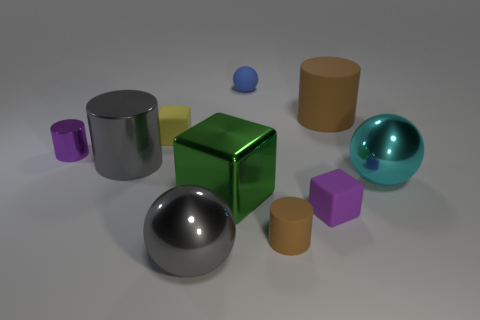Subtract all purple cylinders. How many cylinders are left? 3 Subtract all cyan spheres. How many spheres are left? 2 Subtract all spheres. How many objects are left? 7 Subtract 2 blocks. How many blocks are left? 1 Add 4 small purple shiny cylinders. How many small purple shiny cylinders are left? 5 Add 8 gray cylinders. How many gray cylinders exist? 9 Subtract 0 red cubes. How many objects are left? 10 Subtract all red cylinders. Subtract all green balls. How many cylinders are left? 4 Subtract all red blocks. How many red cylinders are left? 0 Subtract all tiny rubber cylinders. Subtract all tiny cylinders. How many objects are left? 7 